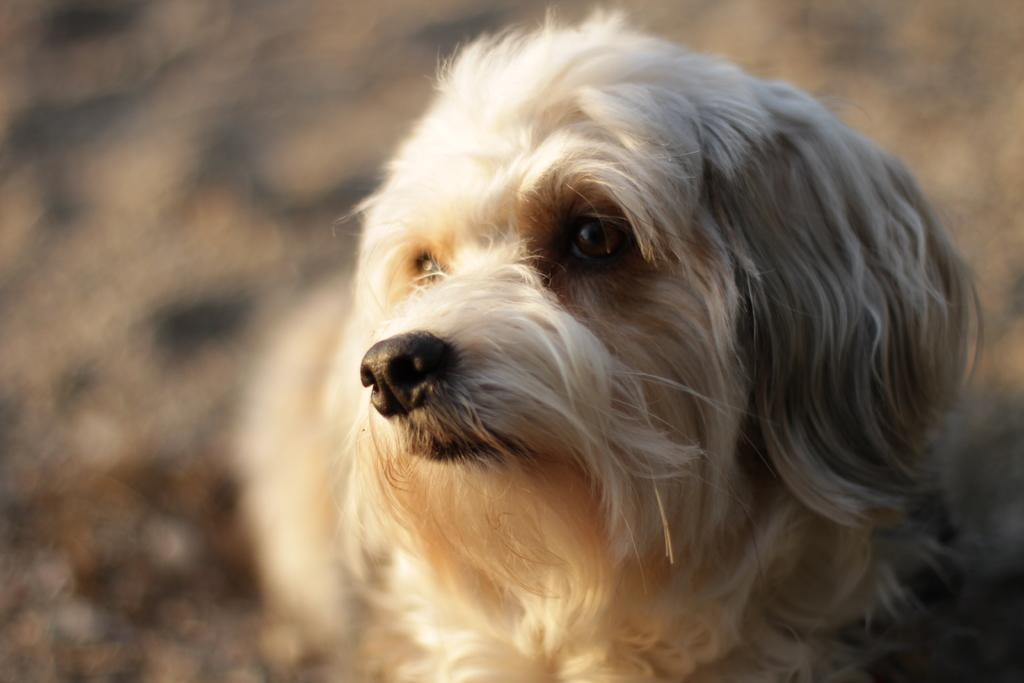What type of animal is present in the image? There is a dog in the image. What is the color of the dog in the image? The dog is white in color. What type of yam is the dog holding in the image? There is no yam present in the image, and the dog is not holding anything. 